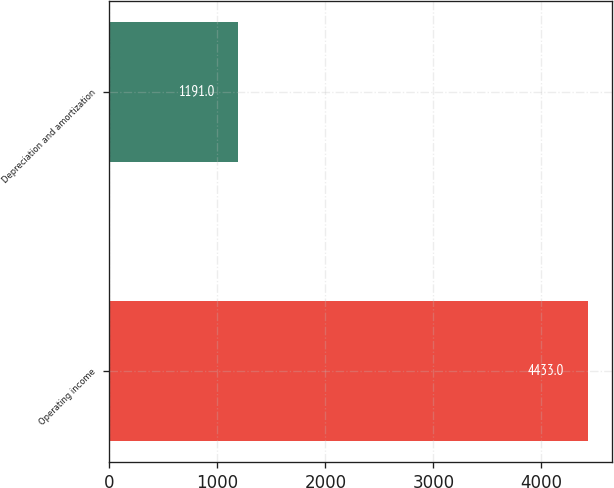<chart> <loc_0><loc_0><loc_500><loc_500><bar_chart><fcel>Operating income<fcel>Depreciation and amortization<nl><fcel>4433<fcel>1191<nl></chart> 